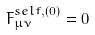<formula> <loc_0><loc_0><loc_500><loc_500>F ^ { s e l f , ( 0 ) } _ { \mu \nu } = 0</formula> 